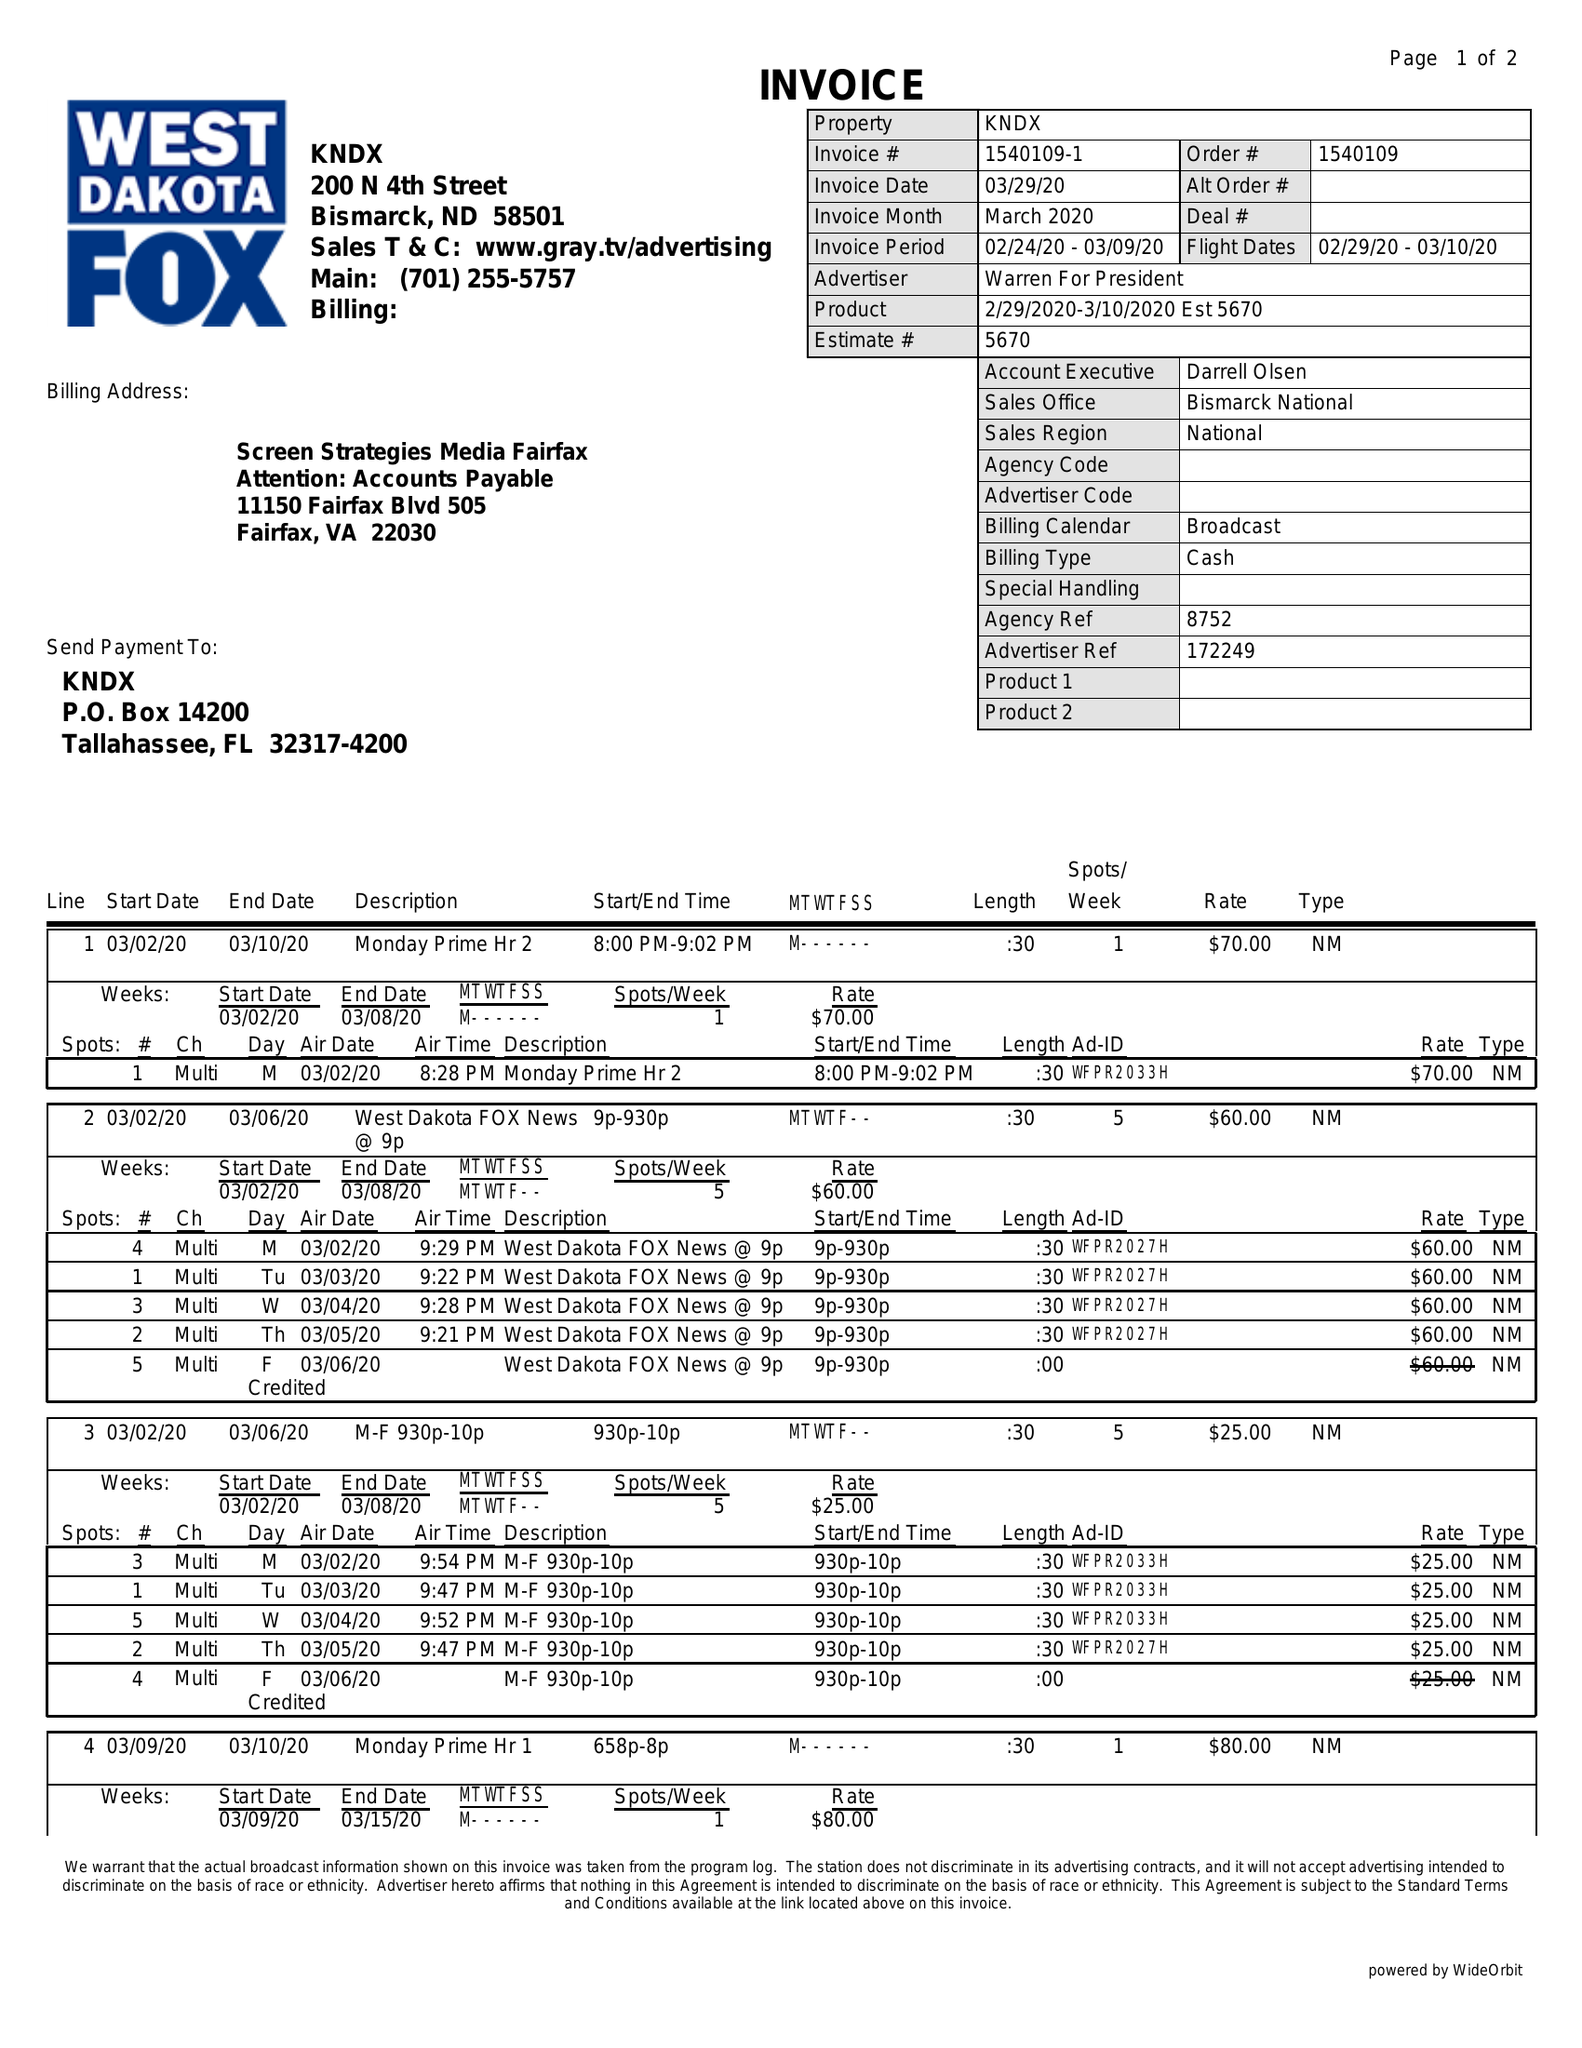What is the value for the contract_num?
Answer the question using a single word or phrase. 1540109 